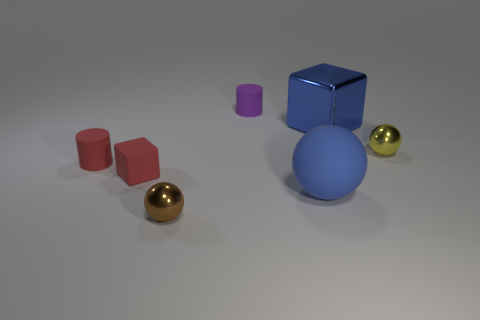There is a sphere that is behind the red cylinder; is it the same color as the tiny matte block?
Offer a terse response. No. There is a small cylinder that is to the left of the tiny purple matte cylinder; what is its material?
Your response must be concise. Rubber. Are there an equal number of shiny things that are on the right side of the tiny purple matte thing and yellow metallic objects?
Offer a very short reply. No. How many matte objects are the same color as the metallic cube?
Your response must be concise. 1. There is another thing that is the same shape as the purple object; what color is it?
Keep it short and to the point. Red. Is the yellow ball the same size as the blue matte thing?
Give a very brief answer. No. Are there the same number of tiny red matte things on the left side of the small red matte cube and large matte spheres that are on the left side of the rubber sphere?
Provide a succinct answer. No. Are any big red matte balls visible?
Provide a succinct answer. No. The red thing that is the same shape as the purple matte object is what size?
Your response must be concise. Small. There is a blue shiny block that is to the right of the purple matte object; what is its size?
Provide a succinct answer. Large. 